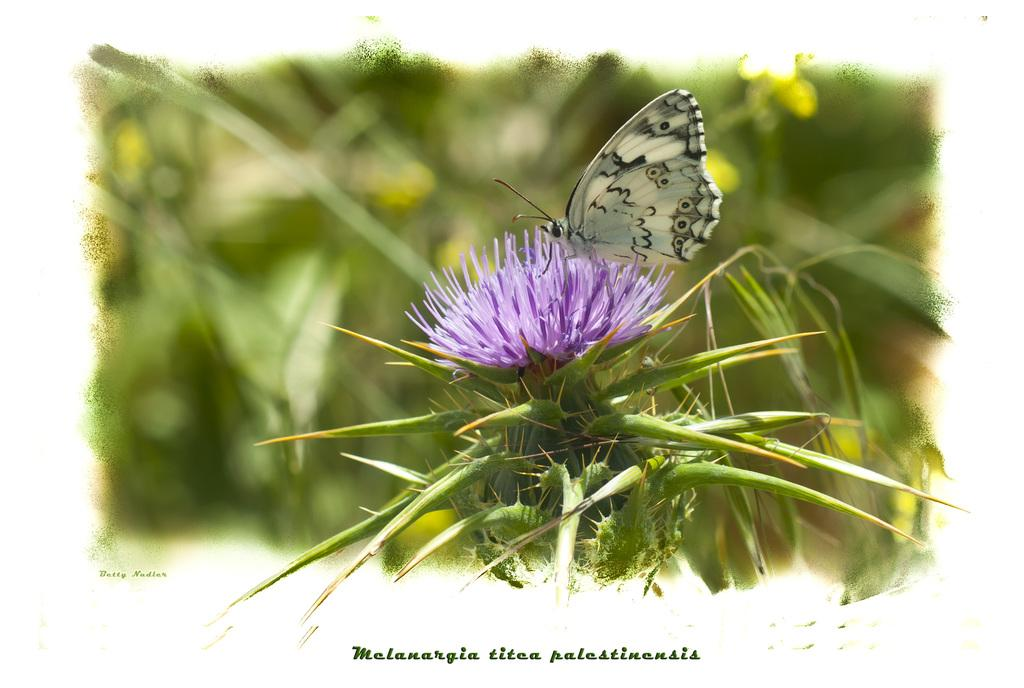What type of living organism can be seen in the image? There is a plant in the image. What is the most prominent feature of the plant? There is a flower on the plant. Is there any other living organism interacting with the plant? Yes, there is a butterfly on the flower. What can be seen at the bottom of the image? There is text visible at the bottom of the image. How would you describe the background of the image? The background of the image is blurry. How much debt does the plant have in the image? There is no information about the plant's debt in the image, as it is not a living organism capable of having debt. What idea does the butterfly represent in the image? The image does not convey any specific ideas or symbolism related to the butterfly; it is simply a butterfly on a flower. 